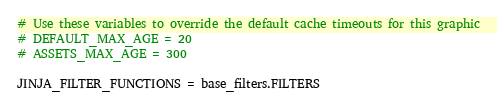Convert code to text. <code><loc_0><loc_0><loc_500><loc_500><_Python_>
# Use these variables to override the default cache timeouts for this graphic
# DEFAULT_MAX_AGE = 20
# ASSETS_MAX_AGE = 300

JINJA_FILTER_FUNCTIONS = base_filters.FILTERS
</code> 